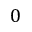<formula> <loc_0><loc_0><loc_500><loc_500>0</formula> 